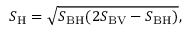<formula> <loc_0><loc_0><loc_500><loc_500>S _ { H } = \sqrt { S _ { B H } ( 2 S _ { B V } - S _ { B H } ) } ,</formula> 